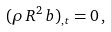<formula> <loc_0><loc_0><loc_500><loc_500>( \rho \, R ^ { 2 } \, b ) _ { , t } = 0 \, ,</formula> 